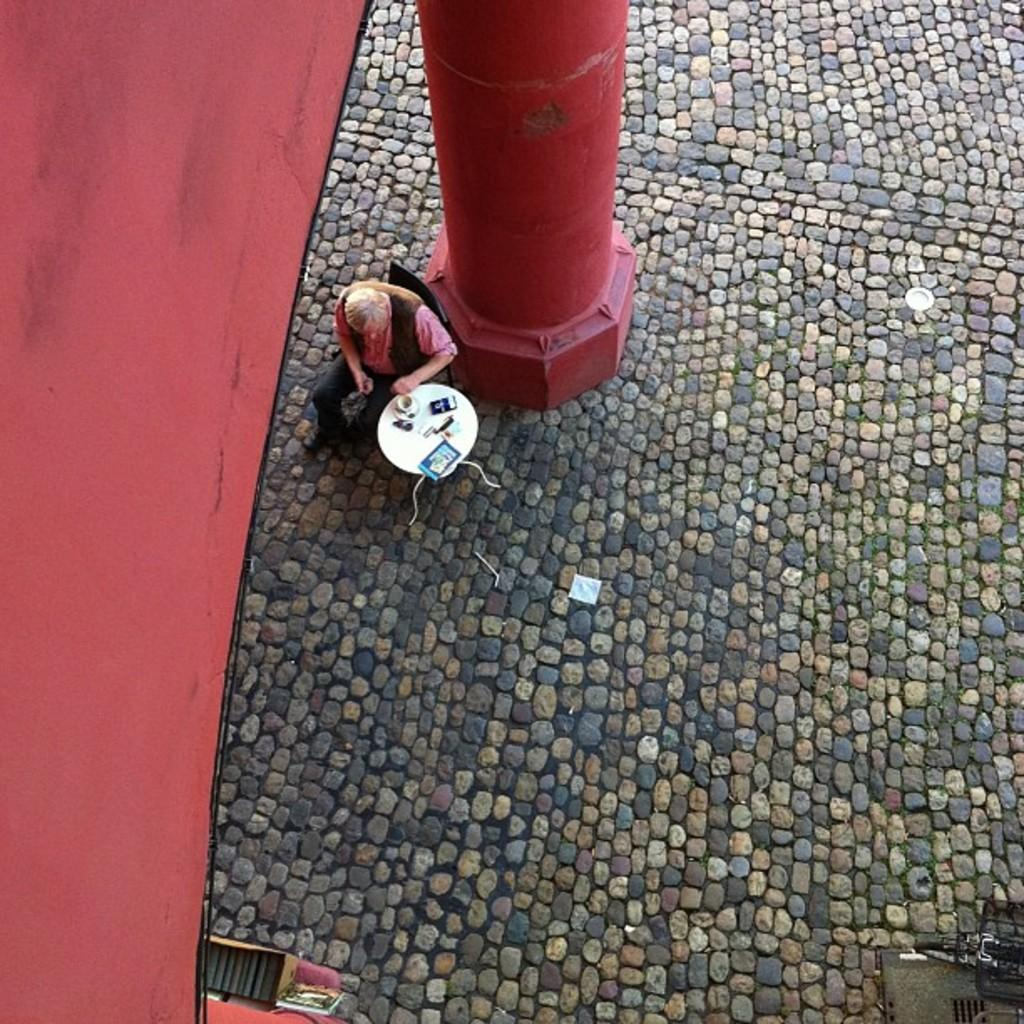What is the man in the image doing? The man is sitting on a chair in the image. What is in front of the man? There is a table in front of the man. What architectural feature can be seen in the image? There is a pillar in the image. What color is the wall on the left side of the image? The wall on the left side of the image is red. Where is the sheep located in the image? There is no sheep present in the image. What type of stove is visible in the image? There is no stove present in the image. 